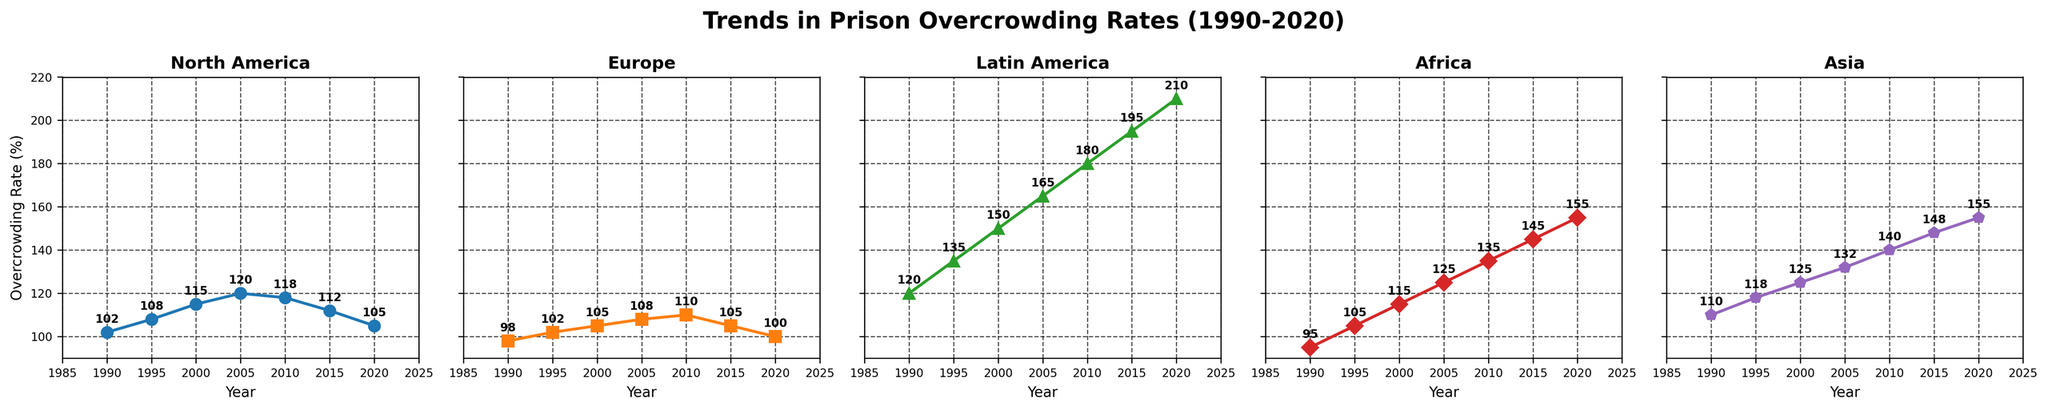What is the overcrowding rate trend for Latin America from 1990 to 2020? The plot for Latin America shows values increasing from 120% in 1990 to 210% in 2020. This indicates a steadily rising trend over the three decades.
Answer: Steadily increasing Which region had the lowest overcrowding rate in 2020, and what is the value? By examining the end points of all lines in the 2020 section, Europe had the lowest value at 100%.
Answer: Europe, 100% How does the 2010 overcrowding rate in Asia compare to that in North America? In 2010, Asia's rate is 140% while North America's rate is 118%. Asia has a higher rate compared to North America.
Answer: Asia's is higher Which region shows the largest rate increase from 1990 to 2020? Calculate the rate change for each region by subtracting the 1990 value from the 2020 value. Latin America increased from 120% to 210%, a difference of 90%. No other region shows a greater change.
Answer: Latin America Rank the regions by their overcrowding rates in 2020 from highest to lowest. The 2020 values are:
- Latin America: 210%
- Africa: 155%
- Asia: 155%
- North America: 105%
- Europe: 100%
Ranking from highest to lowest: Latin America > Africa/Asia > North America > Europe.
Answer: Latin America, Africa/Asia, North America, Europe What is the average overcrowding rate in Europe over the three decades? Calculate the average: (98 + 102 + 105 + 108 + 110 + 105 + 100) / 7 = 728 / 7 = 104%
Answer: 104% In which decade did North America's overcrowding rate peak, and what was the value? North America's highest value is 120% in 2005. This is in the 2000-2010 decade.
Answer: 2000-2010, 120% Which region has the most fluctuating trend and how can you tell? By visual inspection, Latin America's line rises quickly with noticeable larger jumps every 5 years, indicating the most fluctuation.
Answer: Latin America Which regions had a reduction in overcrowding rates after peaking, and what are the peak values? North America peaked at 120% in 2005, then declined to 105% by 2020. Europe peaked at 110% in 2010, then fell to 100% by 2020. Both regions saw reductions after peaking.
Answer: North America (120%), Europe (110%) 